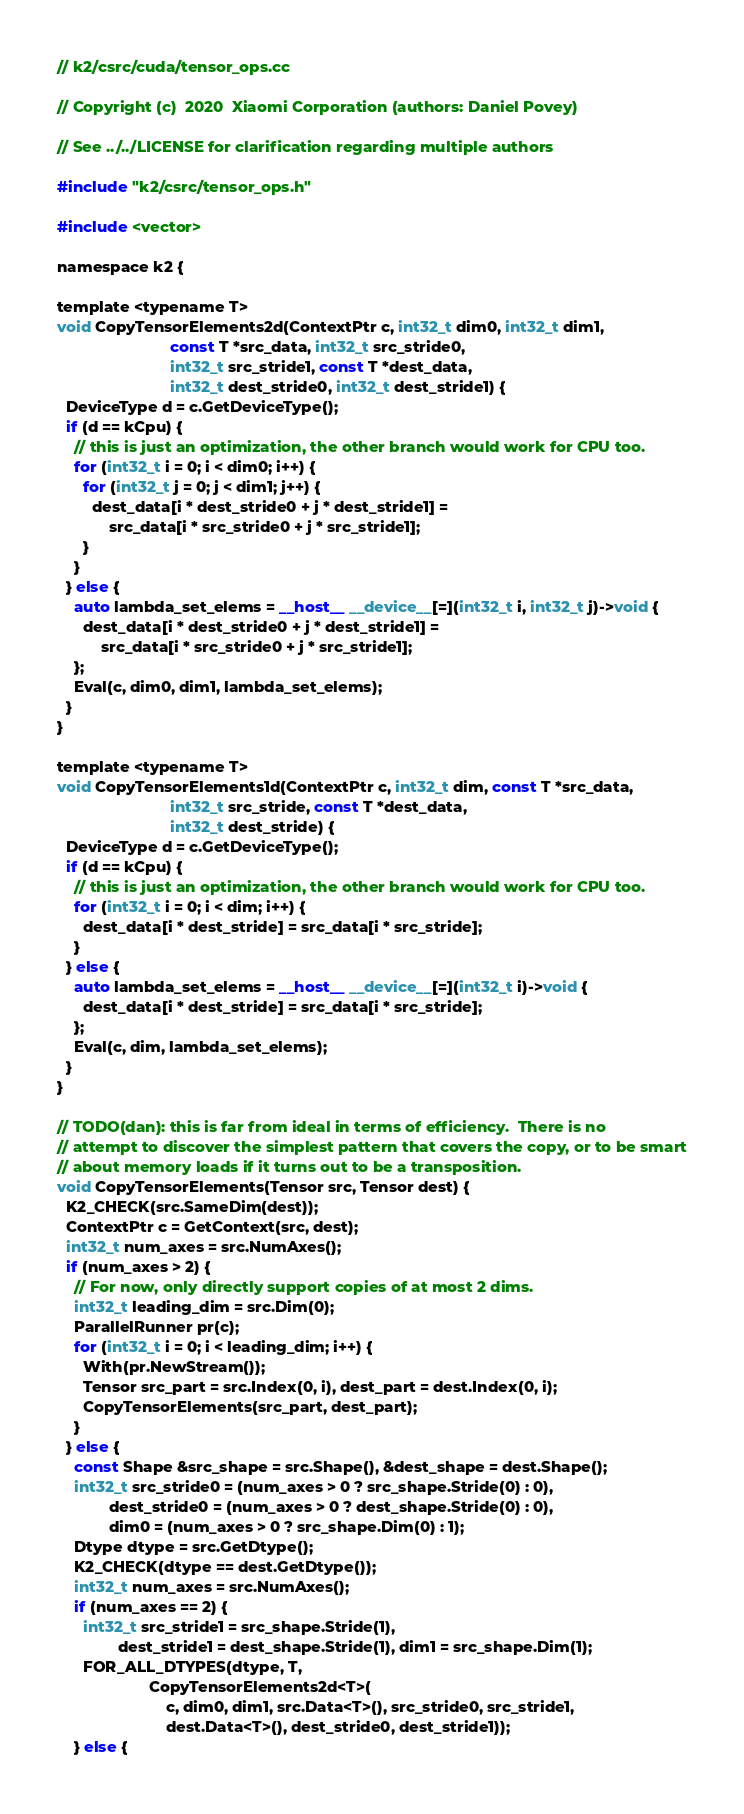Convert code to text. <code><loc_0><loc_0><loc_500><loc_500><_Cuda_>// k2/csrc/cuda/tensor_ops.cc

// Copyright (c)  2020  Xiaomi Corporation (authors: Daniel Povey)

// See ../../LICENSE for clarification regarding multiple authors

#include "k2/csrc/tensor_ops.h"

#include <vector>

namespace k2 {

template <typename T>
void CopyTensorElements2d(ContextPtr c, int32_t dim0, int32_t dim1,
                          const T *src_data, int32_t src_stride0,
                          int32_t src_stride1, const T *dest_data,
                          int32_t dest_stride0, int32_t dest_stride1) {
  DeviceType d = c.GetDeviceType();
  if (d == kCpu) {
    // this is just an optimization, the other branch would work for CPU too.
    for (int32_t i = 0; i < dim0; i++) {
      for (int32_t j = 0; j < dim1; j++) {
        dest_data[i * dest_stride0 + j * dest_stride1] =
            src_data[i * src_stride0 + j * src_stride1];
      }
    }
  } else {
    auto lambda_set_elems = __host__ __device__[=](int32_t i, int32_t j)->void {
      dest_data[i * dest_stride0 + j * dest_stride1] =
          src_data[i * src_stride0 + j * src_stride1];
    };
    Eval(c, dim0, dim1, lambda_set_elems);
  }
}

template <typename T>
void CopyTensorElements1d(ContextPtr c, int32_t dim, const T *src_data,
                          int32_t src_stride, const T *dest_data,
                          int32_t dest_stride) {
  DeviceType d = c.GetDeviceType();
  if (d == kCpu) {
    // this is just an optimization, the other branch would work for CPU too.
    for (int32_t i = 0; i < dim; i++) {
      dest_data[i * dest_stride] = src_data[i * src_stride];
    }
  } else {
    auto lambda_set_elems = __host__ __device__[=](int32_t i)->void {
      dest_data[i * dest_stride] = src_data[i * src_stride];
    };
    Eval(c, dim, lambda_set_elems);
  }
}

// TODO(dan): this is far from ideal in terms of efficiency.  There is no
// attempt to discover the simplest pattern that covers the copy, or to be smart
// about memory loads if it turns out to be a transposition.
void CopyTensorElements(Tensor src, Tensor dest) {
  K2_CHECK(src.SameDim(dest));
  ContextPtr c = GetContext(src, dest);
  int32_t num_axes = src.NumAxes();
  if (num_axes > 2) {
    // For now, only directly support copies of at most 2 dims.
    int32_t leading_dim = src.Dim(0);
    ParallelRunner pr(c);
    for (int32_t i = 0; i < leading_dim; i++) {
      With(pr.NewStream());
      Tensor src_part = src.Index(0, i), dest_part = dest.Index(0, i);
      CopyTensorElements(src_part, dest_part);
    }
  } else {
    const Shape &src_shape = src.Shape(), &dest_shape = dest.Shape();
    int32_t src_stride0 = (num_axes > 0 ? src_shape.Stride(0) : 0),
            dest_stride0 = (num_axes > 0 ? dest_shape.Stride(0) : 0),
            dim0 = (num_axes > 0 ? src_shape.Dim(0) : 1);
    Dtype dtype = src.GetDtype();
    K2_CHECK(dtype == dest.GetDtype());
    int32_t num_axes = src.NumAxes();
    if (num_axes == 2) {
      int32_t src_stride1 = src_shape.Stride(1),
              dest_stride1 = dest_shape.Stride(1), dim1 = src_shape.Dim(1);
      FOR_ALL_DTYPES(dtype, T,
                     CopyTensorElements2d<T>(
                         c, dim0, dim1, src.Data<T>(), src_stride0, src_stride1,
                         dest.Data<T>(), dest_stride0, dest_stride1));
    } else {</code> 